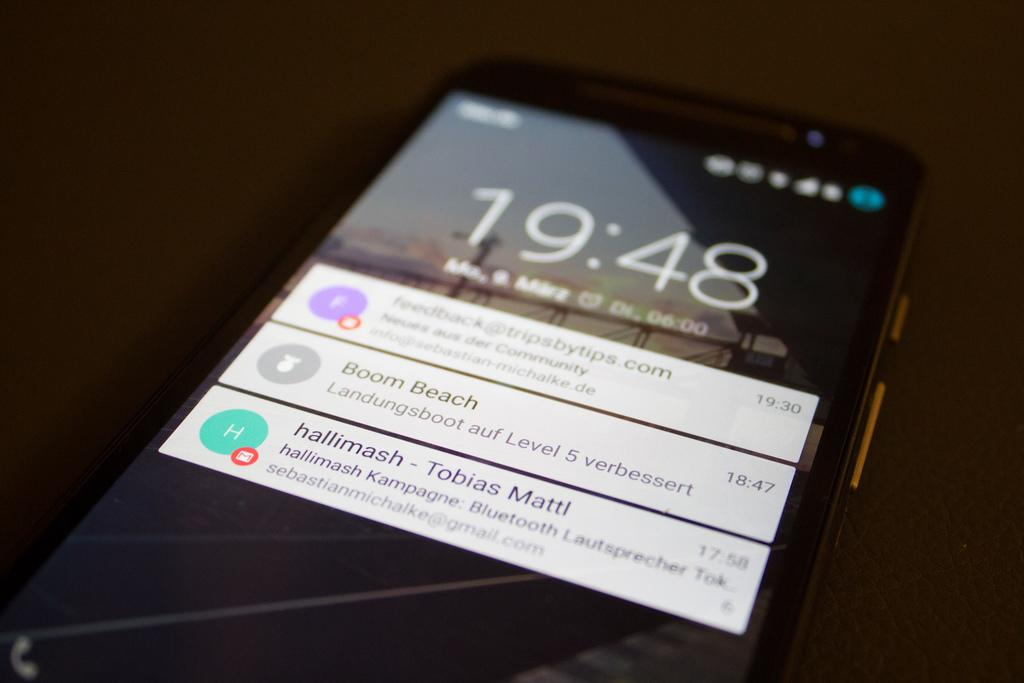<image>
Present a compact description of the photo's key features. a phone with the time written on it that reads 19:48 